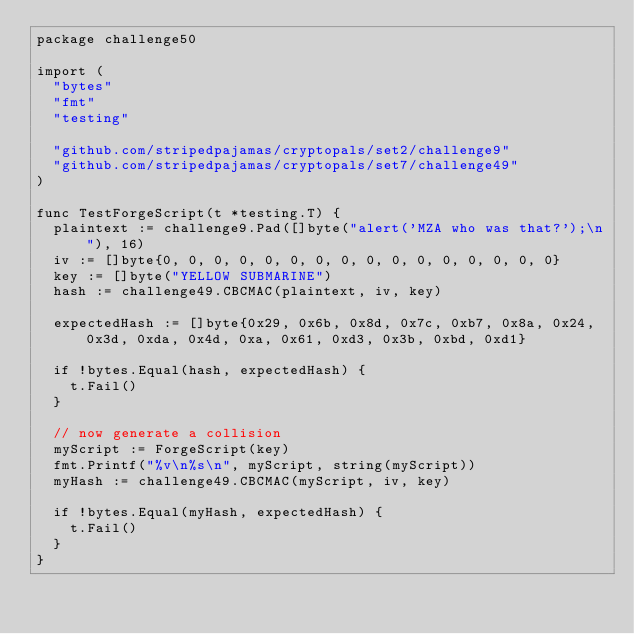Convert code to text. <code><loc_0><loc_0><loc_500><loc_500><_Go_>package challenge50

import (
	"bytes"
	"fmt"
	"testing"

	"github.com/stripedpajamas/cryptopals/set2/challenge9"
	"github.com/stripedpajamas/cryptopals/set7/challenge49"
)

func TestForgeScript(t *testing.T) {
	plaintext := challenge9.Pad([]byte("alert('MZA who was that?');\n"), 16)
	iv := []byte{0, 0, 0, 0, 0, 0, 0, 0, 0, 0, 0, 0, 0, 0, 0, 0}
	key := []byte("YELLOW SUBMARINE")
	hash := challenge49.CBCMAC(plaintext, iv, key)

	expectedHash := []byte{0x29, 0x6b, 0x8d, 0x7c, 0xb7, 0x8a, 0x24, 0x3d, 0xda, 0x4d, 0xa, 0x61, 0xd3, 0x3b, 0xbd, 0xd1}

	if !bytes.Equal(hash, expectedHash) {
		t.Fail()
	}

	// now generate a collision
	myScript := ForgeScript(key)
	fmt.Printf("%v\n%s\n", myScript, string(myScript))
	myHash := challenge49.CBCMAC(myScript, iv, key)

	if !bytes.Equal(myHash, expectedHash) {
		t.Fail()
	}
}
</code> 